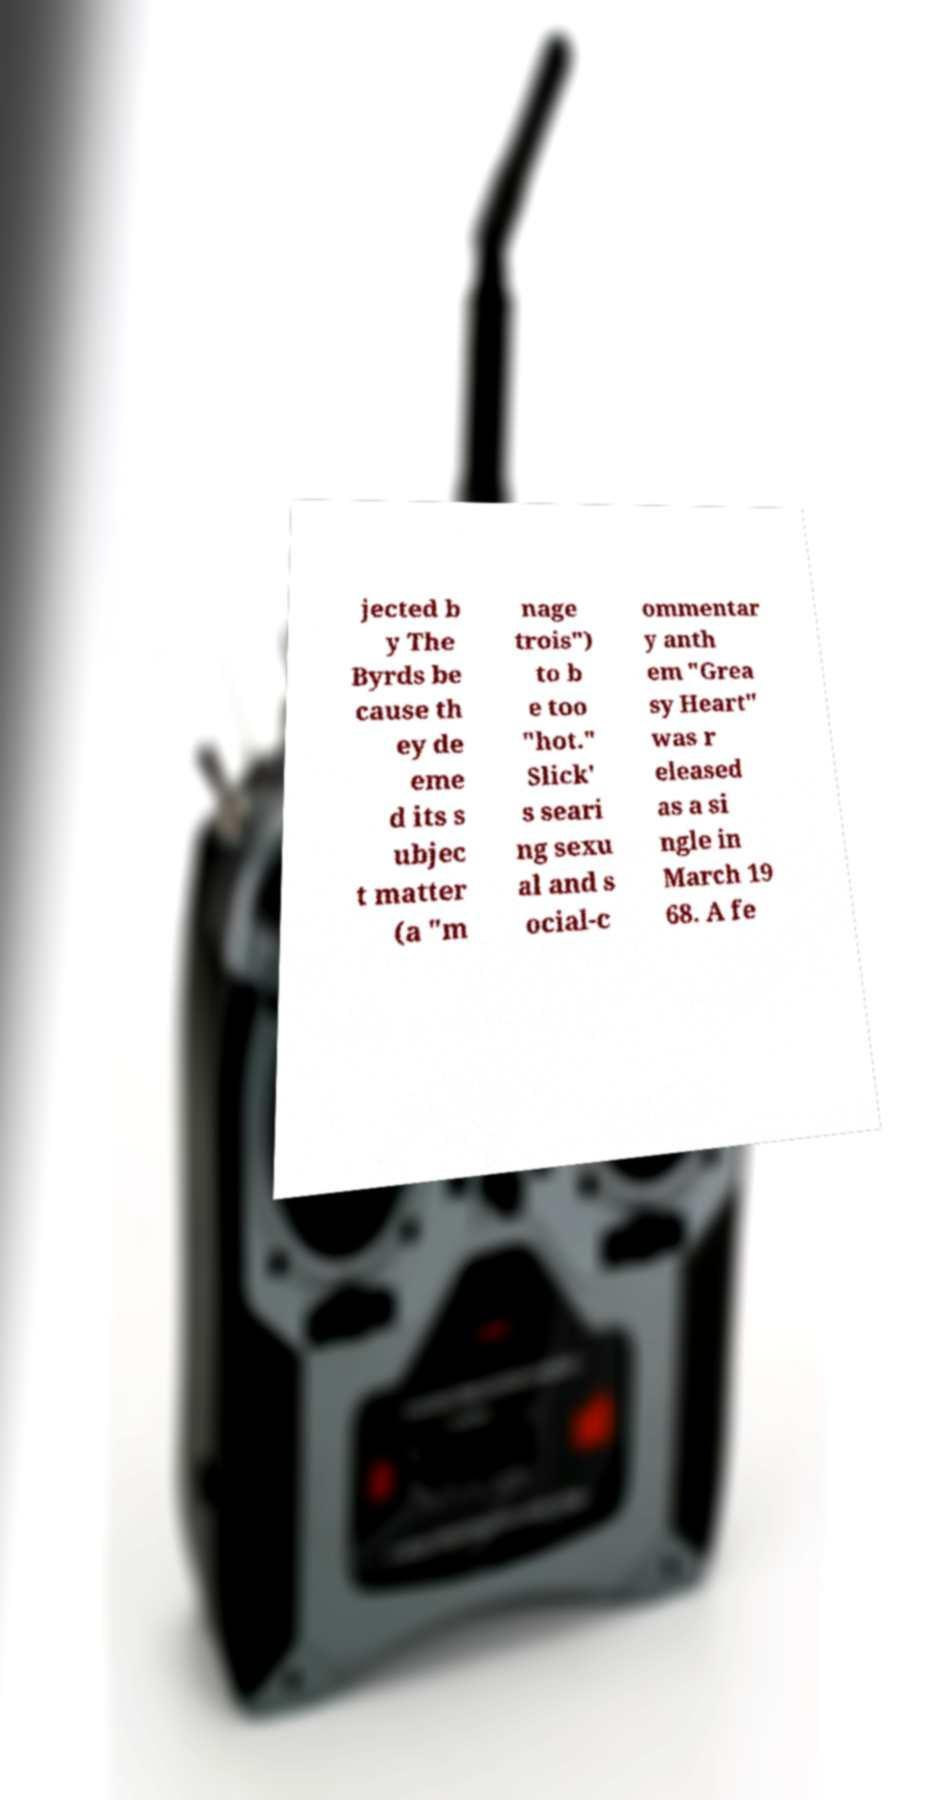Please identify and transcribe the text found in this image. jected b y The Byrds be cause th ey de eme d its s ubjec t matter (a "m nage trois") to b e too "hot." Slick' s seari ng sexu al and s ocial-c ommentar y anth em "Grea sy Heart" was r eleased as a si ngle in March 19 68. A fe 